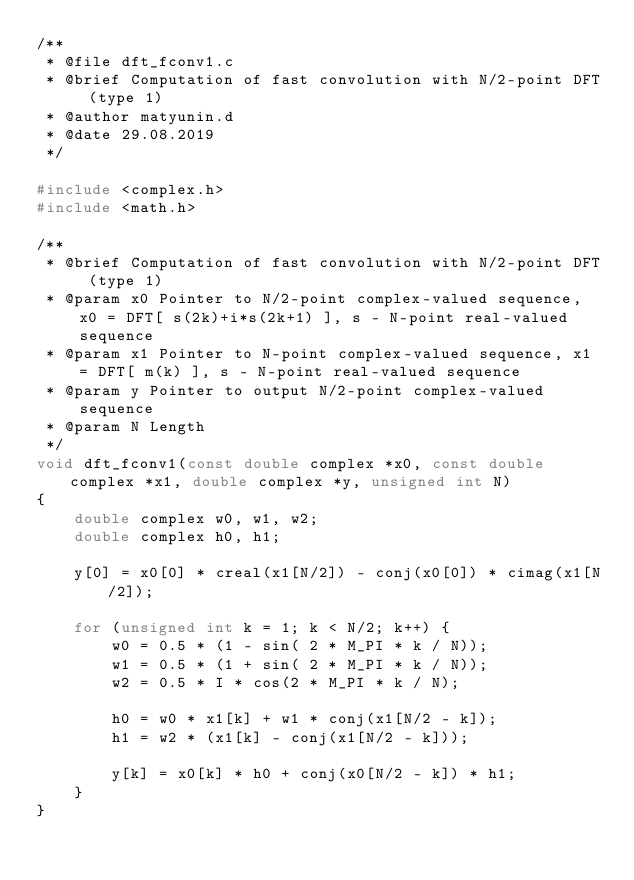<code> <loc_0><loc_0><loc_500><loc_500><_C_>/**
 * @file dft_fconv1.c
 * @brief Computation of fast convolution with N/2-point DFT (type 1)
 * @author matyunin.d
 * @date 29.08.2019
 */

#include <complex.h>
#include <math.h>

/**
 * @brief Computation of fast convolution with N/2-point DFT (type 1)
 * @param x0 Pointer to N/2-point complex-valued sequence, x0 = DFT[ s(2k)+i*s(2k+1) ], s - N-point real-valued sequence
 * @param x1 Pointer to N-point complex-valued sequence, x1 = DFT[ m(k) ], s - N-point real-valued sequence
 * @param y Pointer to output N/2-point complex-valued sequence
 * @param N Length
 */
void dft_fconv1(const double complex *x0, const double complex *x1, double complex *y, unsigned int N)
{
	double complex w0, w1, w2;
	double complex h0, h1;

	y[0] = x0[0] * creal(x1[N/2]) - conj(x0[0]) * cimag(x1[N/2]);

	for (unsigned int k = 1; k < N/2; k++) {
		w0 = 0.5 * (1 - sin( 2 * M_PI * k / N));
		w1 = 0.5 * (1 + sin( 2 * M_PI * k / N));
		w2 = 0.5 * I * cos(2 * M_PI * k / N);

		h0 = w0 * x1[k] + w1 * conj(x1[N/2 - k]);
		h1 = w2 * (x1[k] - conj(x1[N/2 - k]));

		y[k] = x0[k] * h0 + conj(x0[N/2 - k]) * h1;
	}
}

</code> 